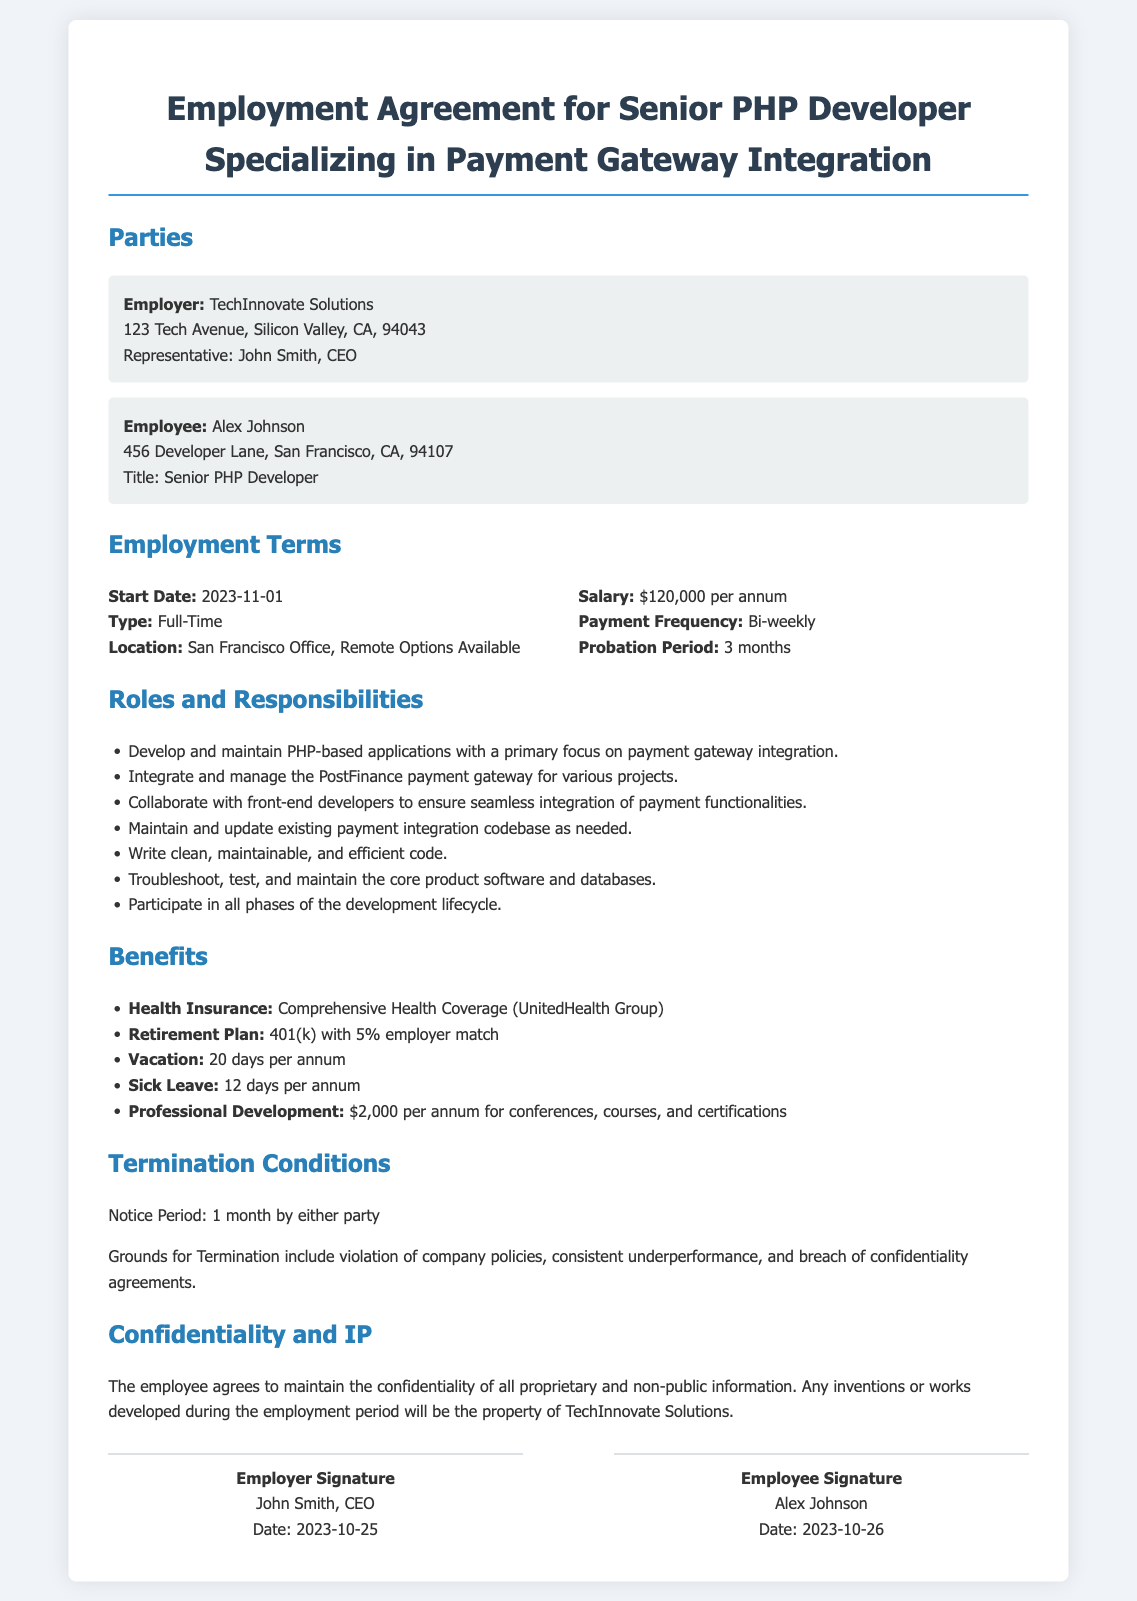What is the employer's name? The employer's name is mentioned at the beginning of the document, which is TechInnovate Solutions.
Answer: TechInnovate Solutions What is the employee's title? The title of the employee is stated in the document, which is Senior PHP Developer.
Answer: Senior PHP Developer What is the salary of the employee? The salary is specified in the employment terms section, which is $120,000 per annum.
Answer: $120,000 per annum What is the probation period? The probation period can be found under employment terms, which is stated as 3 months.
Answer: 3 months What is the notice period for termination? The notice period is indicated in the termination conditions, which is 1 month.
Answer: 1 month What is included in the health insurance benefit? The health insurance coverage is detailed under benefits, which is Comprehensive Health Coverage (UnitedHealth Group).
Answer: Comprehensive Health Coverage (UnitedHealth Group) What is the amount for professional development? The document specifies the budget allocated for professional development activities annually, which is $2,000.
Answer: $2,000 What is the grounds for termination mentioned? Grounds for termination are explained in the termination conditions, which include violation of company policies, consistent underperformance, and breach of confidentiality agreements.
Answer: Violation of company policies, consistent underperformance, and breach of confidentiality agreements Who is the employer's representative? The document states the name of the employer's representative, who is John Smith, CEO.
Answer: John Smith, CEO 